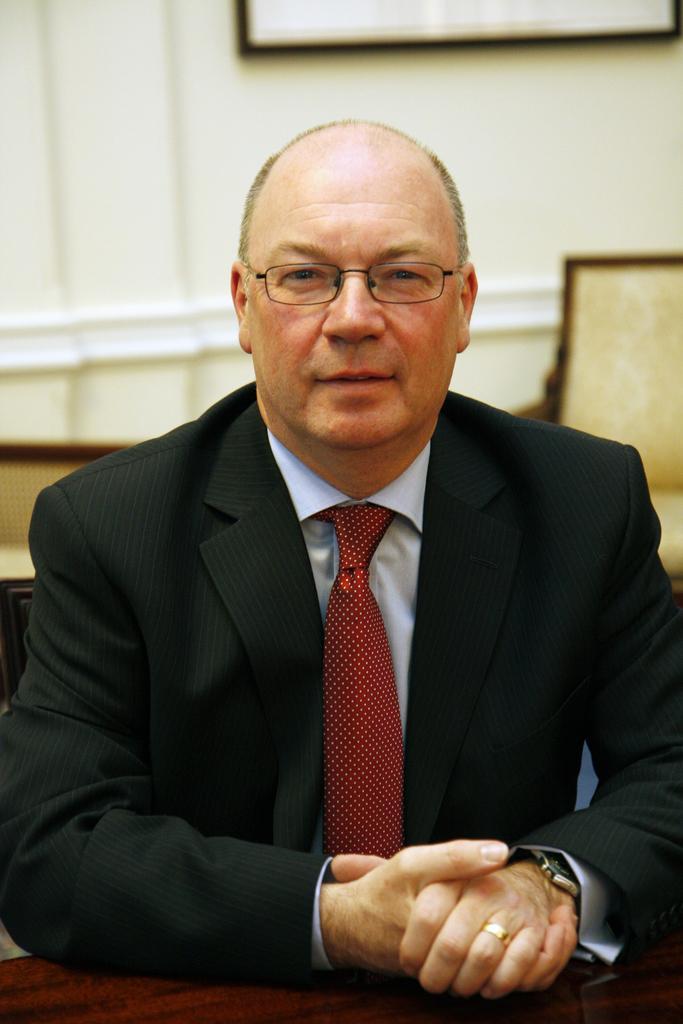Please provide a concise description of this image. In this image we can see the person sitting and at the back there are chairs. And we can see the board attached to the wall. 